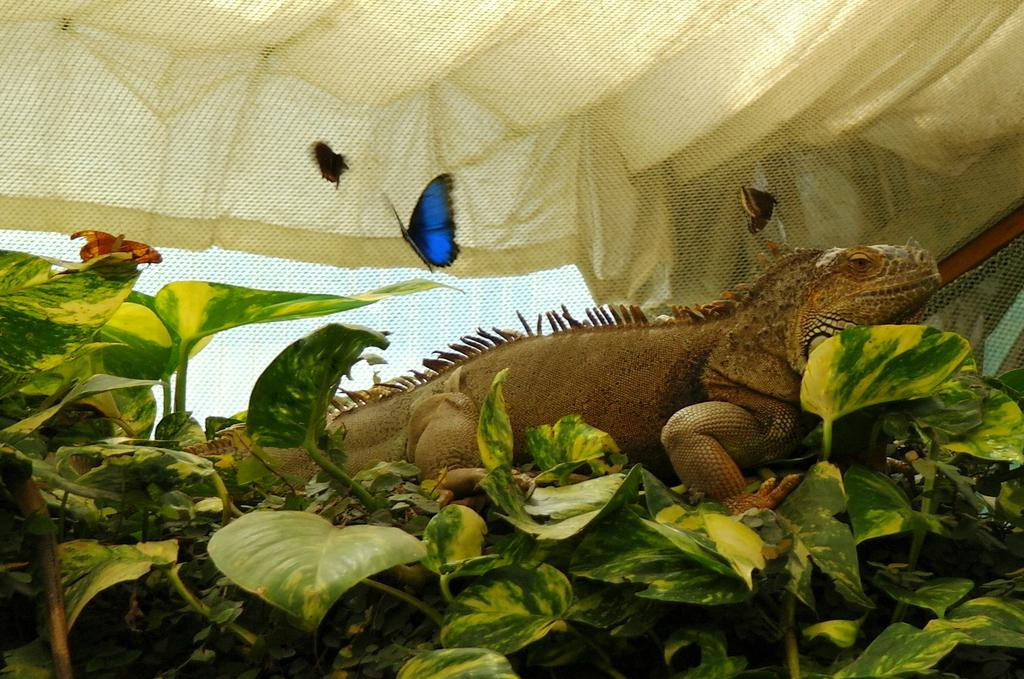What type of animals can be seen in the image? There are butterflies and an iguana in the image. What other living organisms are present in the image? There are plants and a flower in the image. What object is visible in the image that might be used for capturing or restraining? There is a net in the image. What is the topic of the argument taking place in the image? There is no argument present in the image. What historical event is depicted in the image? There is no historical event depicted in the image. 